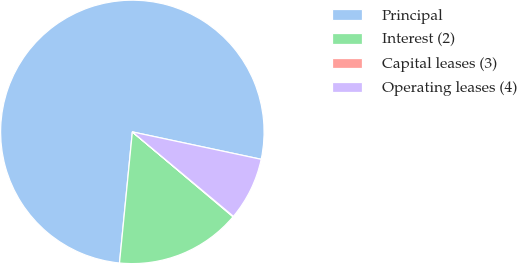Convert chart to OTSL. <chart><loc_0><loc_0><loc_500><loc_500><pie_chart><fcel>Principal<fcel>Interest (2)<fcel>Capital leases (3)<fcel>Operating leases (4)<nl><fcel>76.78%<fcel>15.41%<fcel>0.07%<fcel>7.74%<nl></chart> 